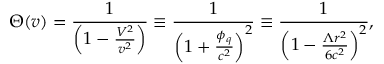<formula> <loc_0><loc_0><loc_500><loc_500>\Theta ( v ) = \frac { 1 } { \left ( 1 - \frac { V ^ { 2 } } { v ^ { 2 } } \right ) } \equiv \frac { 1 } { \left ( 1 + \frac { \phi _ { q } } { c ^ { 2 } } \right ) ^ { 2 } } \equiv \frac { 1 } { \left ( 1 - \frac { \Lambda r ^ { 2 } } { 6 c ^ { 2 } } \right ) ^ { 2 } } ,</formula> 